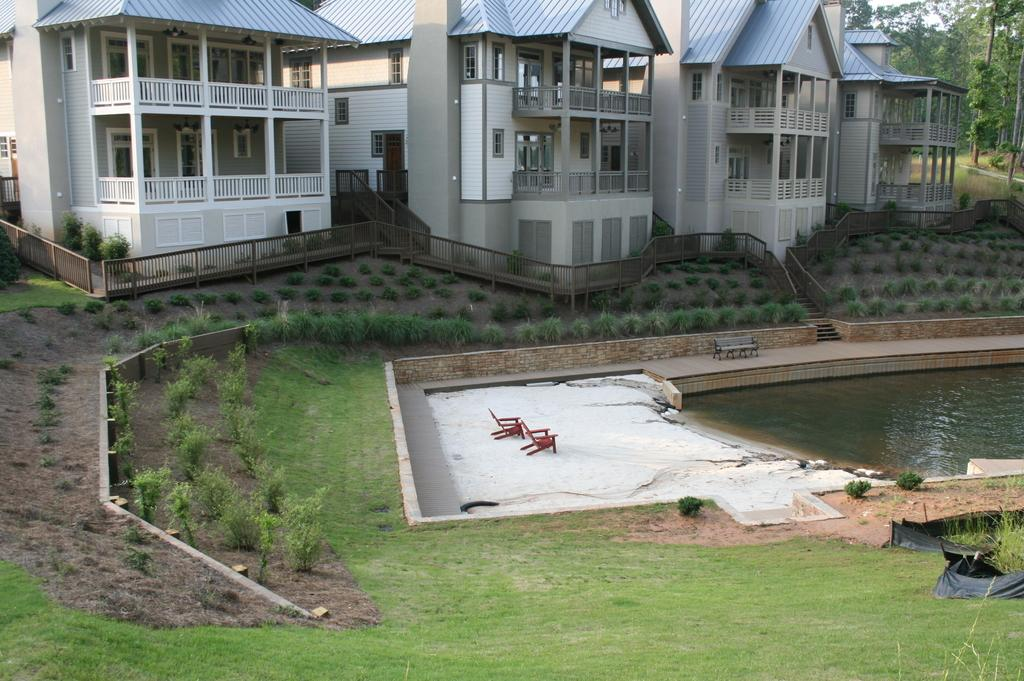How many houses are visible in the image? There are four houses in the image. What is located in front of the houses? There is a big swimming pool in front of the houses. Is the swimming pool used by all the houses? Yes, the swimming pool is shared among the houses. What can be seen in the surroundings of the houses? There is beautiful greenery around the houses. How many boats are tied to the string in the image? There are no boats or strings present in the image. 